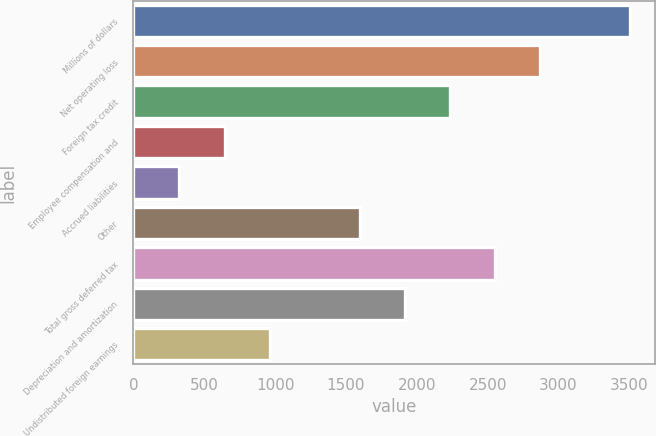<chart> <loc_0><loc_0><loc_500><loc_500><bar_chart><fcel>Millions of dollars<fcel>Net operating loss<fcel>Foreign tax credit<fcel>Employee compensation and<fcel>Accrued liabilities<fcel>Other<fcel>Total gross deferred tax<fcel>Depreciation and amortization<fcel>Undistributed foreign earnings<nl><fcel>3508<fcel>2871.4<fcel>2234.8<fcel>643.3<fcel>325<fcel>1598.2<fcel>2553.1<fcel>1916.5<fcel>961.6<nl></chart> 